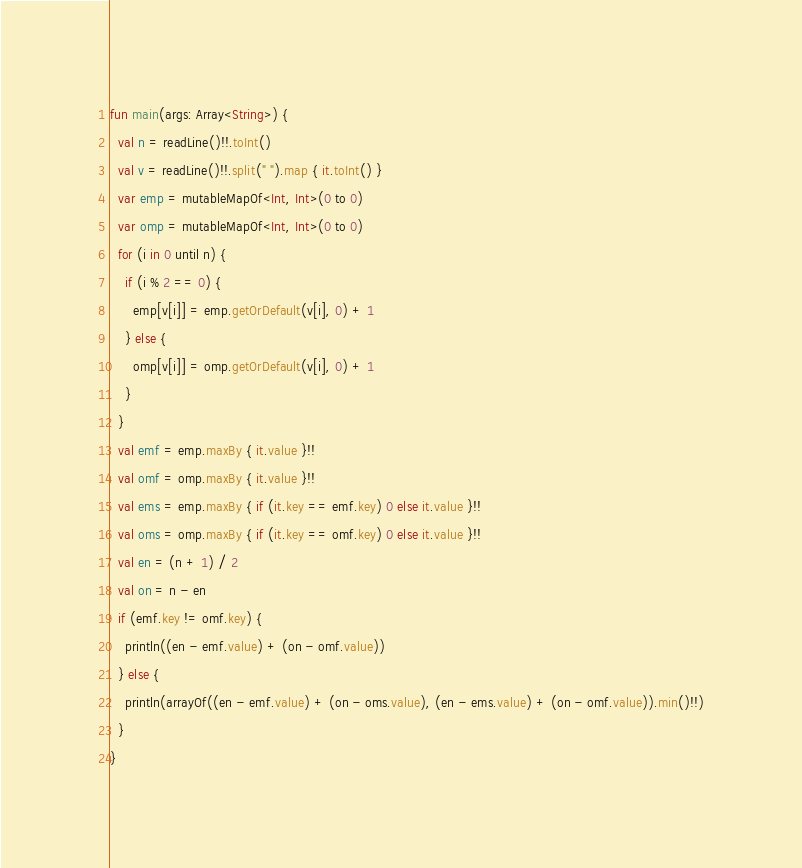Convert code to text. <code><loc_0><loc_0><loc_500><loc_500><_Kotlin_>fun main(args: Array<String>) {
  val n = readLine()!!.toInt()
  val v = readLine()!!.split(" ").map { it.toInt() }
  var emp = mutableMapOf<Int, Int>(0 to 0)
  var omp = mutableMapOf<Int, Int>(0 to 0)
  for (i in 0 until n) {
    if (i % 2 == 0) {
      emp[v[i]] = emp.getOrDefault(v[i], 0) + 1
    } else {
      omp[v[i]] = omp.getOrDefault(v[i], 0) + 1
    }
  }
  val emf = emp.maxBy { it.value }!!
  val omf = omp.maxBy { it.value }!!
  val ems = emp.maxBy { if (it.key == emf.key) 0 else it.value }!!
  val oms = omp.maxBy { if (it.key == omf.key) 0 else it.value }!!
  val en = (n + 1) / 2
  val on = n - en
  if (emf.key != omf.key) {
    println((en - emf.value) + (on - omf.value))
  } else {
    println(arrayOf((en - emf.value) + (on - oms.value), (en - ems.value) + (on - omf.value)).min()!!)
  }
}
</code> 